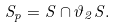Convert formula to latex. <formula><loc_0><loc_0><loc_500><loc_500>S _ { p } = S \cap \vartheta _ { 2 } S .</formula> 